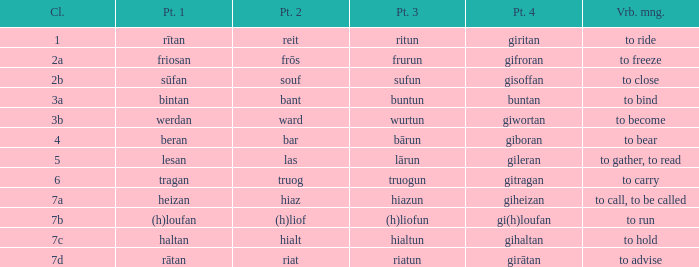Could you help me parse every detail presented in this table? {'header': ['Cl.', 'Pt. 1', 'Pt. 2', 'Pt. 3', 'Pt. 4', 'Vrb. mng.'], 'rows': [['1', 'rītan', 'reit', 'ritun', 'giritan', 'to ride'], ['2a', 'friosan', 'frōs', 'frurun', 'gifroran', 'to freeze'], ['2b', 'sūfan', 'souf', 'sufun', 'gisoffan', 'to close'], ['3a', 'bintan', 'bant', 'buntun', 'buntan', 'to bind'], ['3b', 'werdan', 'ward', 'wurtun', 'giwortan', 'to become'], ['4', 'beran', 'bar', 'bārun', 'giboran', 'to bear'], ['5', 'lesan', 'las', 'lārun', 'gileran', 'to gather, to read'], ['6', 'tragan', 'truog', 'truogun', 'gitragan', 'to carry'], ['7a', 'heizan', 'hiaz', 'hiazun', 'giheizan', 'to call, to be called'], ['7b', '(h)loufan', '(h)liof', '(h)liofun', 'gi(h)loufan', 'to run'], ['7c', 'haltan', 'hialt', 'hialtun', 'gihaltan', 'to hold'], ['7d', 'rātan', 'riat', 'riatun', 'girātan', 'to advise']]} What is the part 3 of the word in class 7a? Hiazun. 